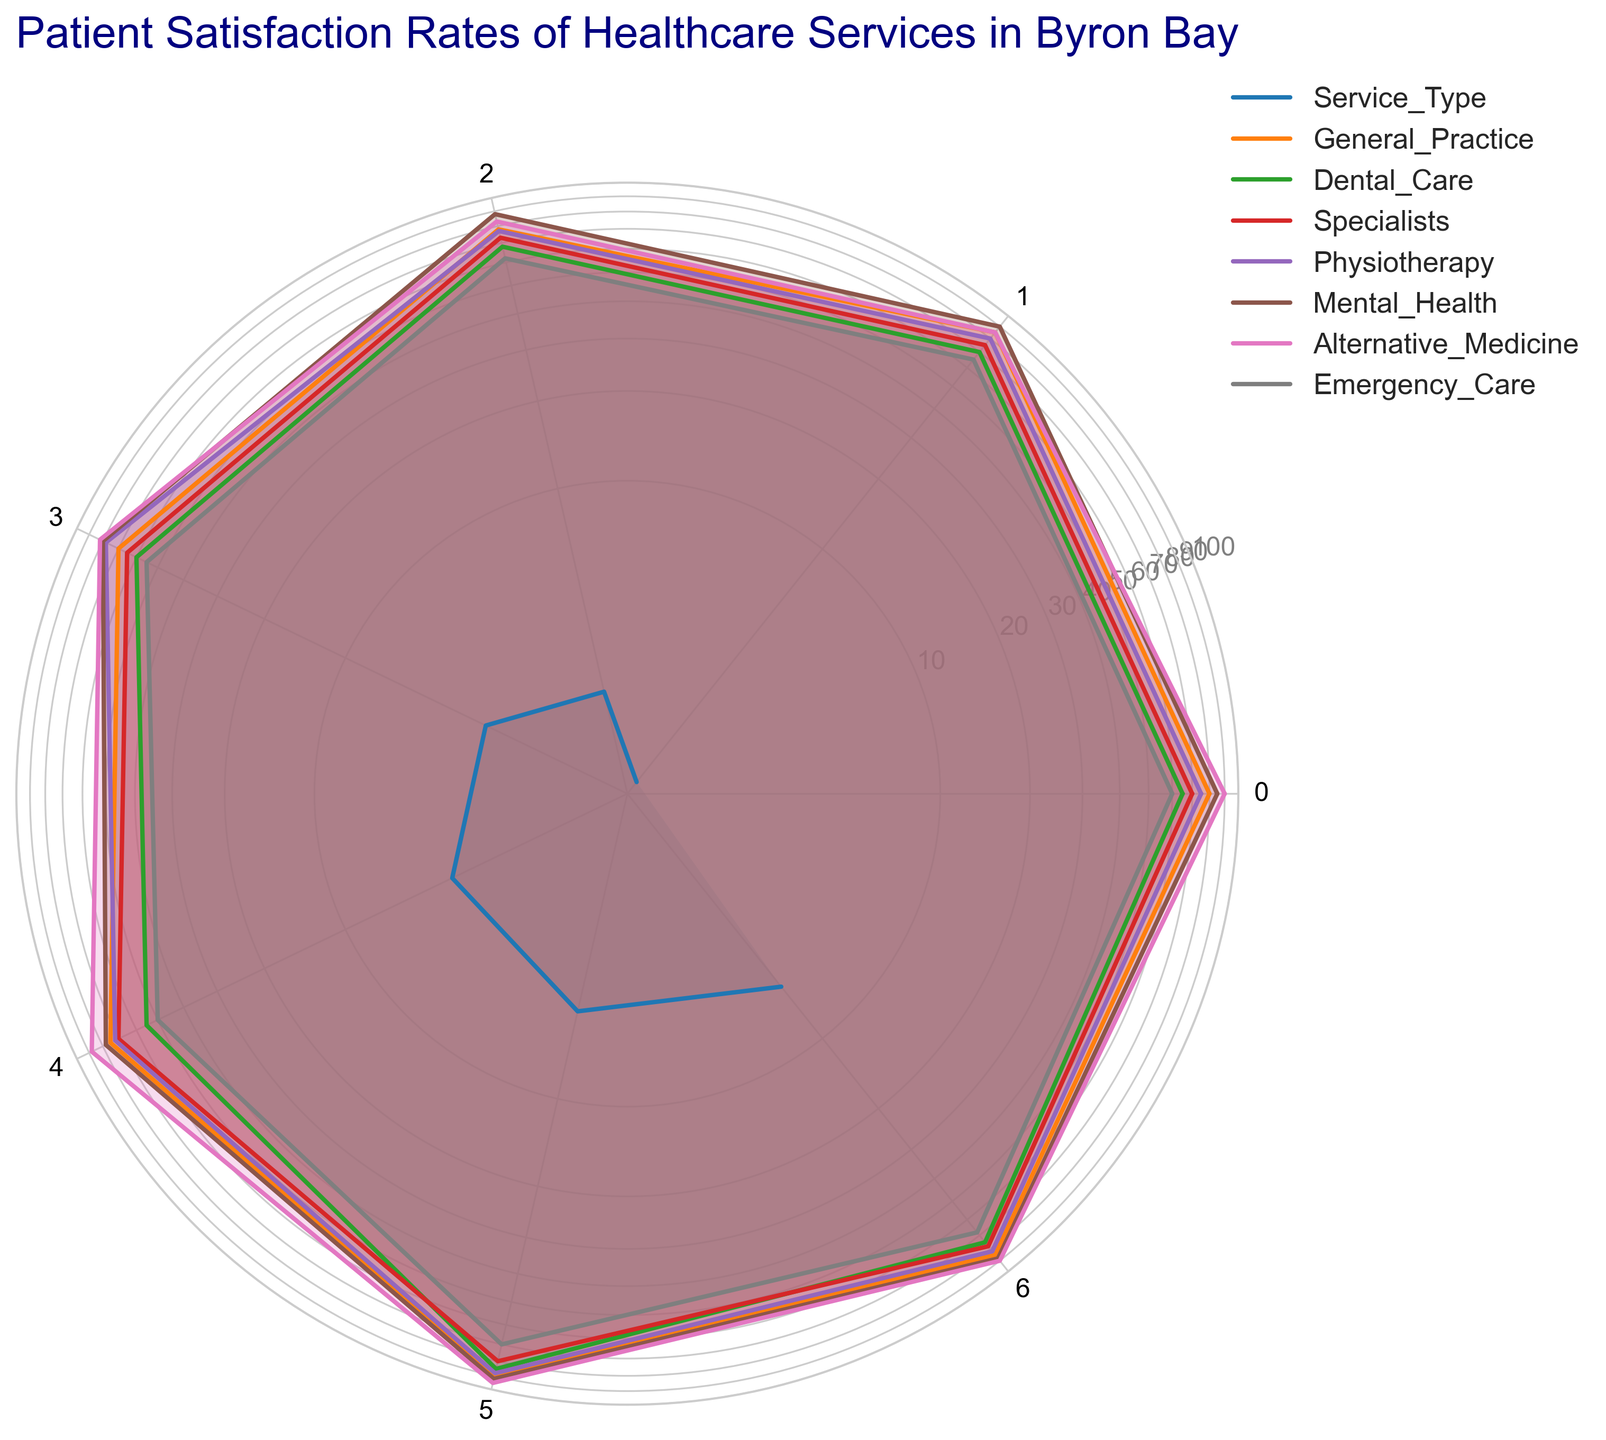What is the highest satisfaction rate for the category "Facility Cleanliness" by service type? Find the column for "Facility Cleanliness" and observe the maximum value among the service types. The highest number is 95 for Alternative Medicine.
Answer: 95 Which service type has the lowest satisfaction rate for "Timeliness"? Locate the category "Timeliness" and compare the values across service types. Emergency Care has the lowest value at 55.
Answer: Emergency Care Compare the "Access to Care" satisfaction rates between General Practice and Dental Care. Which is higher and by how much? Find the "Access to Care" rates for General Practice (80) and Dental Care (65). Subtract the smaller value from the larger value to find the difference: 80 - 65 = 15. General Practice is higher by 15 points.
Answer: General Practice by 15 How does the overall satisfaction for "Mental Health" compare to "Emergency Care"? Look at the category "Overall Satisfaction" and compare the values for Mental Health (88) and Emergency Care (68). 88 is higher than 68.
Answer: Mental Health is higher What is the average satisfaction rate for "Quality of Care" across all service types? Sum the values for "Quality of Care" across all service types: 85 + 70 + 75 + 80 + 90 + 85 + 65 = 550. Divide by the number of service types (7): 550 / 7 ≈ 78.57.
Answer: 78.57 Which service type had the most even spread of satisfaction rates across all categories? Identify the service type whose values do not have large differences among categories. Mental Health (85, 90, 88, 80, 78, 92, 88) has more consistent values across categories.
Answer: Mental Health Is the cost satisfaction higher for Alternative Medicine or Physiotherapy, and by how much? Compare the "Cost Satisfaction" rates for Alternative Medicine (88) and Physiotherapy (72). Calculate the difference: 88 - 72 = 16. Alternative Medicine is higher by 16 points.
Answer: Alternative Medicine by 16 What is the combined satisfaction rate of "Communication Skills" for Dental Care and Specialists? Add the "Communication Skills" values for Dental Care (68) and Specialists (73): 68 + 73 = 141.
Answer: 141 Which service type has a higher "Access to Care" satisfaction rate, General Practice or Alternative Medicine, and by how much? Compare the "Access to Care" rates for General Practice (80) and Alternative Medicine (90). Calculate the difference: 90 - 80 = 10. Alternative Medicine is higher by 10 points.
Answer: Alternative Medicine by 10 If you were to rank "Emergency Care" and "Specialists" based on their "Facility Cleanliness", which would be ranked higher? Compare the "Facility Cleanliness" rates for Emergency Care (70) and Specialists (80). Specialists have a higher rate.
Answer: Specialists 